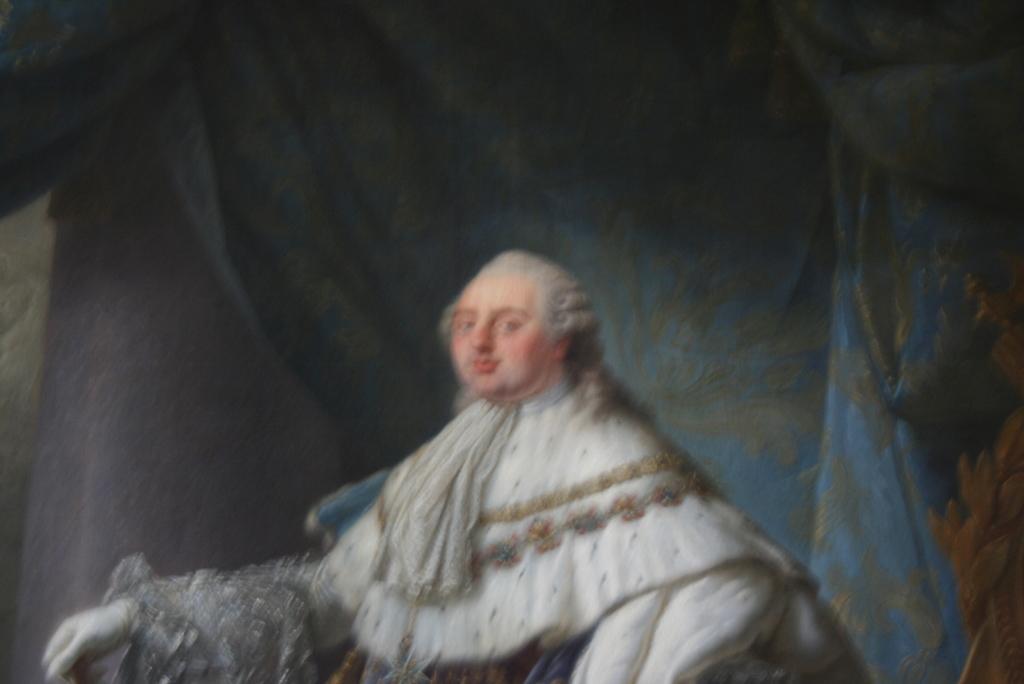How would you summarize this image in a sentence or two? This picture is blur, we can see a statue of a person. In the background we can see curtains. 